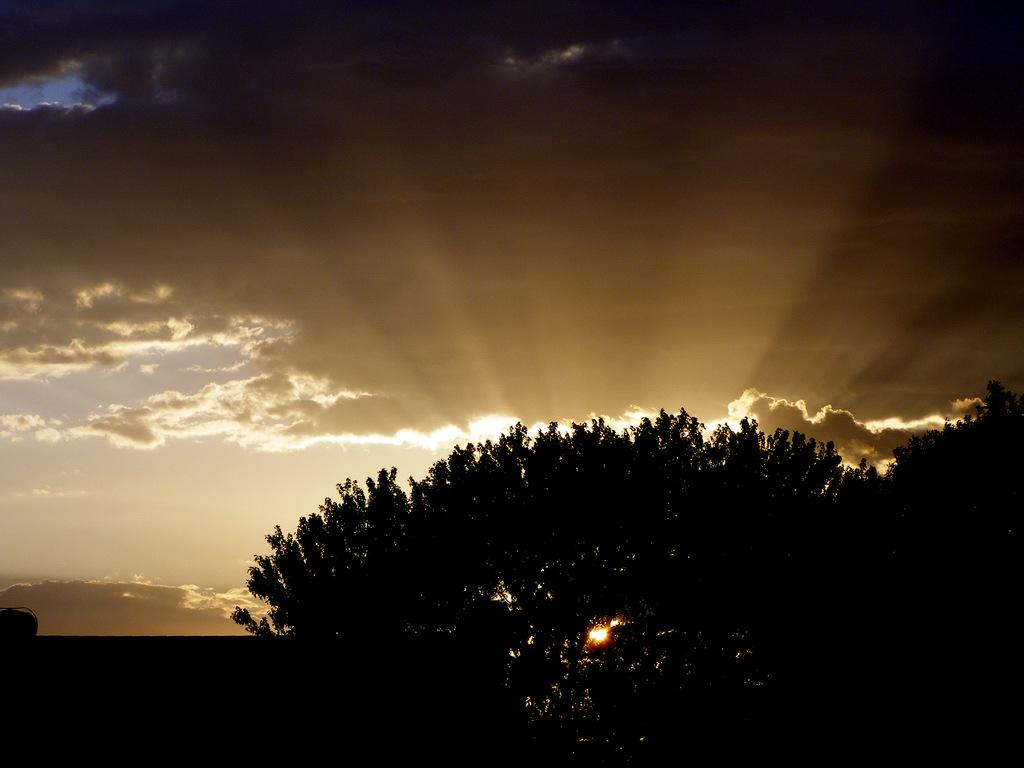What type of natural object can be seen in the image? There is a tree in the image. What part of the natural environment is visible in the image? The sky is visible in the image. What can be seen in the sky in the image? Clouds are present in the sky, and the sun is visible in the sky. What type of fabric is being used to make the tree's leaves in the image? The tree's leaves are not made of fabric; they are natural plant structures. What type of wish can be granted by touching the clouds in the image? There is no mention of wishes or cloud-touching in the image; it simply shows a tree and a sky with clouds and the sun. 